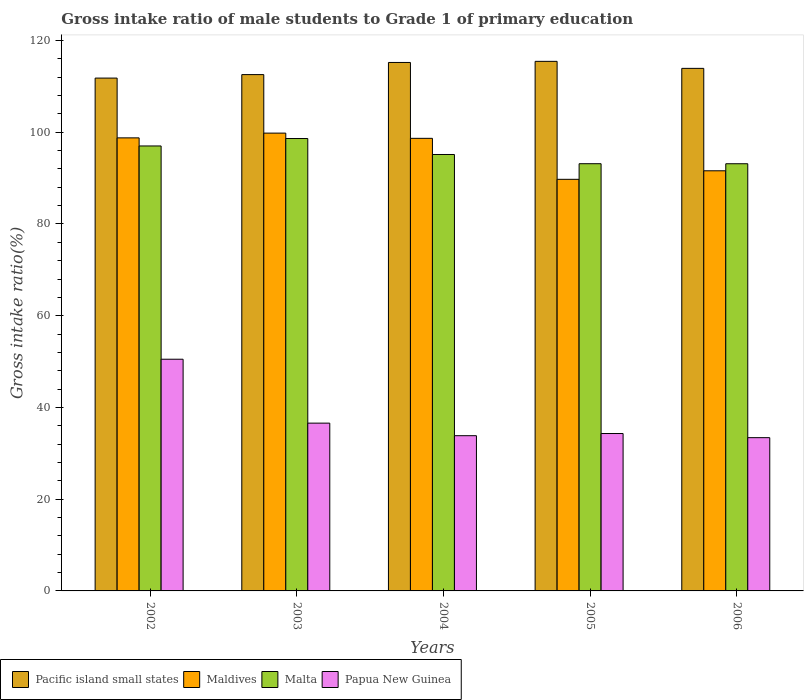How many different coloured bars are there?
Your response must be concise. 4. How many groups of bars are there?
Give a very brief answer. 5. How many bars are there on the 1st tick from the left?
Offer a very short reply. 4. How many bars are there on the 4th tick from the right?
Provide a succinct answer. 4. What is the gross intake ratio in Pacific island small states in 2004?
Your response must be concise. 115.21. Across all years, what is the maximum gross intake ratio in Maldives?
Keep it short and to the point. 99.81. Across all years, what is the minimum gross intake ratio in Pacific island small states?
Provide a short and direct response. 111.81. In which year was the gross intake ratio in Pacific island small states maximum?
Make the answer very short. 2005. What is the total gross intake ratio in Pacific island small states in the graph?
Provide a succinct answer. 568.95. What is the difference between the gross intake ratio in Malta in 2003 and that in 2005?
Offer a terse response. 5.49. What is the difference between the gross intake ratio in Maldives in 2005 and the gross intake ratio in Papua New Guinea in 2002?
Offer a very short reply. 39.22. What is the average gross intake ratio in Pacific island small states per year?
Your answer should be compact. 113.79. In the year 2004, what is the difference between the gross intake ratio in Maldives and gross intake ratio in Papua New Guinea?
Give a very brief answer. 64.83. In how many years, is the gross intake ratio in Malta greater than 32 %?
Your answer should be compact. 5. What is the ratio of the gross intake ratio in Maldives in 2003 to that in 2005?
Make the answer very short. 1.11. Is the gross intake ratio in Papua New Guinea in 2003 less than that in 2004?
Offer a terse response. No. Is the difference between the gross intake ratio in Maldives in 2002 and 2005 greater than the difference between the gross intake ratio in Papua New Guinea in 2002 and 2005?
Make the answer very short. No. What is the difference between the highest and the second highest gross intake ratio in Papua New Guinea?
Give a very brief answer. 13.93. What is the difference between the highest and the lowest gross intake ratio in Papua New Guinea?
Offer a terse response. 17.1. In how many years, is the gross intake ratio in Pacific island small states greater than the average gross intake ratio in Pacific island small states taken over all years?
Your response must be concise. 3. What does the 3rd bar from the left in 2003 represents?
Your answer should be very brief. Malta. What does the 3rd bar from the right in 2005 represents?
Ensure brevity in your answer.  Maldives. How many years are there in the graph?
Provide a short and direct response. 5. Are the values on the major ticks of Y-axis written in scientific E-notation?
Your response must be concise. No. How many legend labels are there?
Your response must be concise. 4. What is the title of the graph?
Make the answer very short. Gross intake ratio of male students to Grade 1 of primary education. What is the label or title of the Y-axis?
Offer a terse response. Gross intake ratio(%). What is the Gross intake ratio(%) of Pacific island small states in 2002?
Keep it short and to the point. 111.81. What is the Gross intake ratio(%) in Maldives in 2002?
Provide a succinct answer. 98.77. What is the Gross intake ratio(%) of Malta in 2002?
Keep it short and to the point. 97.01. What is the Gross intake ratio(%) in Papua New Guinea in 2002?
Make the answer very short. 50.51. What is the Gross intake ratio(%) in Pacific island small states in 2003?
Make the answer very short. 112.56. What is the Gross intake ratio(%) in Maldives in 2003?
Make the answer very short. 99.81. What is the Gross intake ratio(%) in Malta in 2003?
Give a very brief answer. 98.63. What is the Gross intake ratio(%) in Papua New Guinea in 2003?
Make the answer very short. 36.58. What is the Gross intake ratio(%) in Pacific island small states in 2004?
Offer a very short reply. 115.21. What is the Gross intake ratio(%) of Maldives in 2004?
Offer a very short reply. 98.67. What is the Gross intake ratio(%) in Malta in 2004?
Your answer should be compact. 95.15. What is the Gross intake ratio(%) in Papua New Guinea in 2004?
Give a very brief answer. 33.84. What is the Gross intake ratio(%) of Pacific island small states in 2005?
Keep it short and to the point. 115.45. What is the Gross intake ratio(%) in Maldives in 2005?
Your answer should be compact. 89.74. What is the Gross intake ratio(%) of Malta in 2005?
Give a very brief answer. 93.14. What is the Gross intake ratio(%) of Papua New Guinea in 2005?
Offer a terse response. 34.31. What is the Gross intake ratio(%) in Pacific island small states in 2006?
Make the answer very short. 113.92. What is the Gross intake ratio(%) in Maldives in 2006?
Make the answer very short. 91.59. What is the Gross intake ratio(%) in Malta in 2006?
Provide a succinct answer. 93.13. What is the Gross intake ratio(%) in Papua New Guinea in 2006?
Give a very brief answer. 33.41. Across all years, what is the maximum Gross intake ratio(%) in Pacific island small states?
Your answer should be very brief. 115.45. Across all years, what is the maximum Gross intake ratio(%) of Maldives?
Give a very brief answer. 99.81. Across all years, what is the maximum Gross intake ratio(%) of Malta?
Give a very brief answer. 98.63. Across all years, what is the maximum Gross intake ratio(%) of Papua New Guinea?
Keep it short and to the point. 50.51. Across all years, what is the minimum Gross intake ratio(%) in Pacific island small states?
Provide a short and direct response. 111.81. Across all years, what is the minimum Gross intake ratio(%) of Maldives?
Offer a very short reply. 89.74. Across all years, what is the minimum Gross intake ratio(%) of Malta?
Provide a short and direct response. 93.13. Across all years, what is the minimum Gross intake ratio(%) in Papua New Guinea?
Make the answer very short. 33.41. What is the total Gross intake ratio(%) in Pacific island small states in the graph?
Offer a terse response. 568.95. What is the total Gross intake ratio(%) in Maldives in the graph?
Give a very brief answer. 478.57. What is the total Gross intake ratio(%) in Malta in the graph?
Give a very brief answer. 477.05. What is the total Gross intake ratio(%) in Papua New Guinea in the graph?
Provide a succinct answer. 188.66. What is the difference between the Gross intake ratio(%) of Pacific island small states in 2002 and that in 2003?
Provide a short and direct response. -0.76. What is the difference between the Gross intake ratio(%) of Maldives in 2002 and that in 2003?
Your response must be concise. -1.03. What is the difference between the Gross intake ratio(%) in Malta in 2002 and that in 2003?
Keep it short and to the point. -1.62. What is the difference between the Gross intake ratio(%) in Papua New Guinea in 2002 and that in 2003?
Your answer should be compact. 13.93. What is the difference between the Gross intake ratio(%) in Pacific island small states in 2002 and that in 2004?
Keep it short and to the point. -3.4. What is the difference between the Gross intake ratio(%) in Maldives in 2002 and that in 2004?
Your response must be concise. 0.1. What is the difference between the Gross intake ratio(%) in Malta in 2002 and that in 2004?
Give a very brief answer. 1.86. What is the difference between the Gross intake ratio(%) of Papua New Guinea in 2002 and that in 2004?
Provide a succinct answer. 16.67. What is the difference between the Gross intake ratio(%) in Pacific island small states in 2002 and that in 2005?
Give a very brief answer. -3.65. What is the difference between the Gross intake ratio(%) in Maldives in 2002 and that in 2005?
Give a very brief answer. 9.04. What is the difference between the Gross intake ratio(%) in Malta in 2002 and that in 2005?
Your answer should be compact. 3.87. What is the difference between the Gross intake ratio(%) in Papua New Guinea in 2002 and that in 2005?
Your answer should be compact. 16.2. What is the difference between the Gross intake ratio(%) in Pacific island small states in 2002 and that in 2006?
Offer a very short reply. -2.12. What is the difference between the Gross intake ratio(%) in Maldives in 2002 and that in 2006?
Ensure brevity in your answer.  7.18. What is the difference between the Gross intake ratio(%) in Malta in 2002 and that in 2006?
Give a very brief answer. 3.88. What is the difference between the Gross intake ratio(%) in Papua New Guinea in 2002 and that in 2006?
Your answer should be compact. 17.1. What is the difference between the Gross intake ratio(%) of Pacific island small states in 2003 and that in 2004?
Offer a very short reply. -2.64. What is the difference between the Gross intake ratio(%) in Maldives in 2003 and that in 2004?
Keep it short and to the point. 1.14. What is the difference between the Gross intake ratio(%) in Malta in 2003 and that in 2004?
Your response must be concise. 3.48. What is the difference between the Gross intake ratio(%) of Papua New Guinea in 2003 and that in 2004?
Make the answer very short. 2.74. What is the difference between the Gross intake ratio(%) in Pacific island small states in 2003 and that in 2005?
Offer a terse response. -2.89. What is the difference between the Gross intake ratio(%) of Maldives in 2003 and that in 2005?
Keep it short and to the point. 10.07. What is the difference between the Gross intake ratio(%) of Malta in 2003 and that in 2005?
Offer a terse response. 5.49. What is the difference between the Gross intake ratio(%) in Papua New Guinea in 2003 and that in 2005?
Offer a very short reply. 2.27. What is the difference between the Gross intake ratio(%) of Pacific island small states in 2003 and that in 2006?
Give a very brief answer. -1.36. What is the difference between the Gross intake ratio(%) of Maldives in 2003 and that in 2006?
Give a very brief answer. 8.21. What is the difference between the Gross intake ratio(%) in Malta in 2003 and that in 2006?
Ensure brevity in your answer.  5.5. What is the difference between the Gross intake ratio(%) in Papua New Guinea in 2003 and that in 2006?
Make the answer very short. 3.17. What is the difference between the Gross intake ratio(%) in Pacific island small states in 2004 and that in 2005?
Offer a terse response. -0.24. What is the difference between the Gross intake ratio(%) in Maldives in 2004 and that in 2005?
Offer a terse response. 8.93. What is the difference between the Gross intake ratio(%) of Malta in 2004 and that in 2005?
Offer a terse response. 2.01. What is the difference between the Gross intake ratio(%) of Papua New Guinea in 2004 and that in 2005?
Your answer should be compact. -0.47. What is the difference between the Gross intake ratio(%) of Pacific island small states in 2004 and that in 2006?
Offer a very short reply. 1.29. What is the difference between the Gross intake ratio(%) of Maldives in 2004 and that in 2006?
Your answer should be compact. 7.07. What is the difference between the Gross intake ratio(%) in Malta in 2004 and that in 2006?
Your answer should be very brief. 2.02. What is the difference between the Gross intake ratio(%) of Papua New Guinea in 2004 and that in 2006?
Ensure brevity in your answer.  0.43. What is the difference between the Gross intake ratio(%) of Pacific island small states in 2005 and that in 2006?
Make the answer very short. 1.53. What is the difference between the Gross intake ratio(%) of Maldives in 2005 and that in 2006?
Your response must be concise. -1.86. What is the difference between the Gross intake ratio(%) of Malta in 2005 and that in 2006?
Keep it short and to the point. 0.01. What is the difference between the Gross intake ratio(%) in Papua New Guinea in 2005 and that in 2006?
Offer a terse response. 0.9. What is the difference between the Gross intake ratio(%) of Pacific island small states in 2002 and the Gross intake ratio(%) of Maldives in 2003?
Your response must be concise. 12. What is the difference between the Gross intake ratio(%) of Pacific island small states in 2002 and the Gross intake ratio(%) of Malta in 2003?
Your response must be concise. 13.18. What is the difference between the Gross intake ratio(%) of Pacific island small states in 2002 and the Gross intake ratio(%) of Papua New Guinea in 2003?
Offer a terse response. 75.22. What is the difference between the Gross intake ratio(%) of Maldives in 2002 and the Gross intake ratio(%) of Malta in 2003?
Provide a succinct answer. 0.14. What is the difference between the Gross intake ratio(%) of Maldives in 2002 and the Gross intake ratio(%) of Papua New Guinea in 2003?
Your answer should be very brief. 62.19. What is the difference between the Gross intake ratio(%) of Malta in 2002 and the Gross intake ratio(%) of Papua New Guinea in 2003?
Make the answer very short. 60.43. What is the difference between the Gross intake ratio(%) in Pacific island small states in 2002 and the Gross intake ratio(%) in Maldives in 2004?
Offer a very short reply. 13.14. What is the difference between the Gross intake ratio(%) of Pacific island small states in 2002 and the Gross intake ratio(%) of Malta in 2004?
Your answer should be compact. 16.66. What is the difference between the Gross intake ratio(%) in Pacific island small states in 2002 and the Gross intake ratio(%) in Papua New Guinea in 2004?
Offer a terse response. 77.97. What is the difference between the Gross intake ratio(%) in Maldives in 2002 and the Gross intake ratio(%) in Malta in 2004?
Your response must be concise. 3.63. What is the difference between the Gross intake ratio(%) in Maldives in 2002 and the Gross intake ratio(%) in Papua New Guinea in 2004?
Your answer should be compact. 64.93. What is the difference between the Gross intake ratio(%) of Malta in 2002 and the Gross intake ratio(%) of Papua New Guinea in 2004?
Ensure brevity in your answer.  63.17. What is the difference between the Gross intake ratio(%) in Pacific island small states in 2002 and the Gross intake ratio(%) in Maldives in 2005?
Ensure brevity in your answer.  22.07. What is the difference between the Gross intake ratio(%) in Pacific island small states in 2002 and the Gross intake ratio(%) in Malta in 2005?
Your answer should be very brief. 18.67. What is the difference between the Gross intake ratio(%) in Pacific island small states in 2002 and the Gross intake ratio(%) in Papua New Guinea in 2005?
Offer a very short reply. 77.49. What is the difference between the Gross intake ratio(%) in Maldives in 2002 and the Gross intake ratio(%) in Malta in 2005?
Ensure brevity in your answer.  5.63. What is the difference between the Gross intake ratio(%) in Maldives in 2002 and the Gross intake ratio(%) in Papua New Guinea in 2005?
Offer a terse response. 64.46. What is the difference between the Gross intake ratio(%) in Malta in 2002 and the Gross intake ratio(%) in Papua New Guinea in 2005?
Provide a succinct answer. 62.69. What is the difference between the Gross intake ratio(%) in Pacific island small states in 2002 and the Gross intake ratio(%) in Maldives in 2006?
Your answer should be very brief. 20.21. What is the difference between the Gross intake ratio(%) of Pacific island small states in 2002 and the Gross intake ratio(%) of Malta in 2006?
Your response must be concise. 18.68. What is the difference between the Gross intake ratio(%) of Pacific island small states in 2002 and the Gross intake ratio(%) of Papua New Guinea in 2006?
Offer a terse response. 78.39. What is the difference between the Gross intake ratio(%) in Maldives in 2002 and the Gross intake ratio(%) in Malta in 2006?
Your response must be concise. 5.64. What is the difference between the Gross intake ratio(%) of Maldives in 2002 and the Gross intake ratio(%) of Papua New Guinea in 2006?
Give a very brief answer. 65.36. What is the difference between the Gross intake ratio(%) in Malta in 2002 and the Gross intake ratio(%) in Papua New Guinea in 2006?
Give a very brief answer. 63.6. What is the difference between the Gross intake ratio(%) in Pacific island small states in 2003 and the Gross intake ratio(%) in Maldives in 2004?
Your response must be concise. 13.9. What is the difference between the Gross intake ratio(%) in Pacific island small states in 2003 and the Gross intake ratio(%) in Malta in 2004?
Keep it short and to the point. 17.42. What is the difference between the Gross intake ratio(%) of Pacific island small states in 2003 and the Gross intake ratio(%) of Papua New Guinea in 2004?
Your answer should be very brief. 78.72. What is the difference between the Gross intake ratio(%) in Maldives in 2003 and the Gross intake ratio(%) in Malta in 2004?
Give a very brief answer. 4.66. What is the difference between the Gross intake ratio(%) of Maldives in 2003 and the Gross intake ratio(%) of Papua New Guinea in 2004?
Provide a short and direct response. 65.97. What is the difference between the Gross intake ratio(%) in Malta in 2003 and the Gross intake ratio(%) in Papua New Guinea in 2004?
Your response must be concise. 64.79. What is the difference between the Gross intake ratio(%) of Pacific island small states in 2003 and the Gross intake ratio(%) of Maldives in 2005?
Provide a succinct answer. 22.83. What is the difference between the Gross intake ratio(%) in Pacific island small states in 2003 and the Gross intake ratio(%) in Malta in 2005?
Keep it short and to the point. 19.43. What is the difference between the Gross intake ratio(%) in Pacific island small states in 2003 and the Gross intake ratio(%) in Papua New Guinea in 2005?
Give a very brief answer. 78.25. What is the difference between the Gross intake ratio(%) in Maldives in 2003 and the Gross intake ratio(%) in Malta in 2005?
Ensure brevity in your answer.  6.67. What is the difference between the Gross intake ratio(%) of Maldives in 2003 and the Gross intake ratio(%) of Papua New Guinea in 2005?
Your answer should be compact. 65.49. What is the difference between the Gross intake ratio(%) in Malta in 2003 and the Gross intake ratio(%) in Papua New Guinea in 2005?
Provide a succinct answer. 64.31. What is the difference between the Gross intake ratio(%) in Pacific island small states in 2003 and the Gross intake ratio(%) in Maldives in 2006?
Provide a succinct answer. 20.97. What is the difference between the Gross intake ratio(%) in Pacific island small states in 2003 and the Gross intake ratio(%) in Malta in 2006?
Provide a short and direct response. 19.43. What is the difference between the Gross intake ratio(%) of Pacific island small states in 2003 and the Gross intake ratio(%) of Papua New Guinea in 2006?
Offer a very short reply. 79.15. What is the difference between the Gross intake ratio(%) in Maldives in 2003 and the Gross intake ratio(%) in Malta in 2006?
Your response must be concise. 6.67. What is the difference between the Gross intake ratio(%) of Maldives in 2003 and the Gross intake ratio(%) of Papua New Guinea in 2006?
Provide a succinct answer. 66.39. What is the difference between the Gross intake ratio(%) in Malta in 2003 and the Gross intake ratio(%) in Papua New Guinea in 2006?
Make the answer very short. 65.22. What is the difference between the Gross intake ratio(%) in Pacific island small states in 2004 and the Gross intake ratio(%) in Maldives in 2005?
Offer a terse response. 25.47. What is the difference between the Gross intake ratio(%) in Pacific island small states in 2004 and the Gross intake ratio(%) in Malta in 2005?
Your answer should be compact. 22.07. What is the difference between the Gross intake ratio(%) in Pacific island small states in 2004 and the Gross intake ratio(%) in Papua New Guinea in 2005?
Give a very brief answer. 80.89. What is the difference between the Gross intake ratio(%) of Maldives in 2004 and the Gross intake ratio(%) of Malta in 2005?
Your answer should be very brief. 5.53. What is the difference between the Gross intake ratio(%) in Maldives in 2004 and the Gross intake ratio(%) in Papua New Guinea in 2005?
Your answer should be compact. 64.35. What is the difference between the Gross intake ratio(%) of Malta in 2004 and the Gross intake ratio(%) of Papua New Guinea in 2005?
Make the answer very short. 60.83. What is the difference between the Gross intake ratio(%) of Pacific island small states in 2004 and the Gross intake ratio(%) of Maldives in 2006?
Offer a very short reply. 23.61. What is the difference between the Gross intake ratio(%) of Pacific island small states in 2004 and the Gross intake ratio(%) of Malta in 2006?
Offer a terse response. 22.08. What is the difference between the Gross intake ratio(%) in Pacific island small states in 2004 and the Gross intake ratio(%) in Papua New Guinea in 2006?
Provide a short and direct response. 81.8. What is the difference between the Gross intake ratio(%) of Maldives in 2004 and the Gross intake ratio(%) of Malta in 2006?
Ensure brevity in your answer.  5.54. What is the difference between the Gross intake ratio(%) in Maldives in 2004 and the Gross intake ratio(%) in Papua New Guinea in 2006?
Your answer should be compact. 65.26. What is the difference between the Gross intake ratio(%) in Malta in 2004 and the Gross intake ratio(%) in Papua New Guinea in 2006?
Your response must be concise. 61.73. What is the difference between the Gross intake ratio(%) in Pacific island small states in 2005 and the Gross intake ratio(%) in Maldives in 2006?
Ensure brevity in your answer.  23.86. What is the difference between the Gross intake ratio(%) of Pacific island small states in 2005 and the Gross intake ratio(%) of Malta in 2006?
Offer a terse response. 22.32. What is the difference between the Gross intake ratio(%) in Pacific island small states in 2005 and the Gross intake ratio(%) in Papua New Guinea in 2006?
Your answer should be very brief. 82.04. What is the difference between the Gross intake ratio(%) in Maldives in 2005 and the Gross intake ratio(%) in Malta in 2006?
Your answer should be compact. -3.4. What is the difference between the Gross intake ratio(%) in Maldives in 2005 and the Gross intake ratio(%) in Papua New Guinea in 2006?
Keep it short and to the point. 56.32. What is the difference between the Gross intake ratio(%) of Malta in 2005 and the Gross intake ratio(%) of Papua New Guinea in 2006?
Make the answer very short. 59.73. What is the average Gross intake ratio(%) in Pacific island small states per year?
Offer a terse response. 113.79. What is the average Gross intake ratio(%) in Maldives per year?
Keep it short and to the point. 95.71. What is the average Gross intake ratio(%) in Malta per year?
Your response must be concise. 95.41. What is the average Gross intake ratio(%) of Papua New Guinea per year?
Ensure brevity in your answer.  37.73. In the year 2002, what is the difference between the Gross intake ratio(%) in Pacific island small states and Gross intake ratio(%) in Maldives?
Provide a short and direct response. 13.03. In the year 2002, what is the difference between the Gross intake ratio(%) in Pacific island small states and Gross intake ratio(%) in Malta?
Offer a very short reply. 14.8. In the year 2002, what is the difference between the Gross intake ratio(%) in Pacific island small states and Gross intake ratio(%) in Papua New Guinea?
Provide a short and direct response. 61.29. In the year 2002, what is the difference between the Gross intake ratio(%) of Maldives and Gross intake ratio(%) of Malta?
Provide a short and direct response. 1.76. In the year 2002, what is the difference between the Gross intake ratio(%) of Maldives and Gross intake ratio(%) of Papua New Guinea?
Your answer should be compact. 48.26. In the year 2002, what is the difference between the Gross intake ratio(%) in Malta and Gross intake ratio(%) in Papua New Guinea?
Provide a succinct answer. 46.49. In the year 2003, what is the difference between the Gross intake ratio(%) of Pacific island small states and Gross intake ratio(%) of Maldives?
Your answer should be very brief. 12.76. In the year 2003, what is the difference between the Gross intake ratio(%) of Pacific island small states and Gross intake ratio(%) of Malta?
Keep it short and to the point. 13.94. In the year 2003, what is the difference between the Gross intake ratio(%) of Pacific island small states and Gross intake ratio(%) of Papua New Guinea?
Your answer should be very brief. 75.98. In the year 2003, what is the difference between the Gross intake ratio(%) in Maldives and Gross intake ratio(%) in Malta?
Make the answer very short. 1.18. In the year 2003, what is the difference between the Gross intake ratio(%) in Maldives and Gross intake ratio(%) in Papua New Guinea?
Give a very brief answer. 63.23. In the year 2003, what is the difference between the Gross intake ratio(%) in Malta and Gross intake ratio(%) in Papua New Guinea?
Your answer should be compact. 62.05. In the year 2004, what is the difference between the Gross intake ratio(%) of Pacific island small states and Gross intake ratio(%) of Maldives?
Ensure brevity in your answer.  16.54. In the year 2004, what is the difference between the Gross intake ratio(%) in Pacific island small states and Gross intake ratio(%) in Malta?
Give a very brief answer. 20.06. In the year 2004, what is the difference between the Gross intake ratio(%) of Pacific island small states and Gross intake ratio(%) of Papua New Guinea?
Provide a succinct answer. 81.37. In the year 2004, what is the difference between the Gross intake ratio(%) of Maldives and Gross intake ratio(%) of Malta?
Your response must be concise. 3.52. In the year 2004, what is the difference between the Gross intake ratio(%) of Maldives and Gross intake ratio(%) of Papua New Guinea?
Keep it short and to the point. 64.83. In the year 2004, what is the difference between the Gross intake ratio(%) in Malta and Gross intake ratio(%) in Papua New Guinea?
Make the answer very short. 61.31. In the year 2005, what is the difference between the Gross intake ratio(%) in Pacific island small states and Gross intake ratio(%) in Maldives?
Provide a succinct answer. 25.72. In the year 2005, what is the difference between the Gross intake ratio(%) of Pacific island small states and Gross intake ratio(%) of Malta?
Your answer should be compact. 22.31. In the year 2005, what is the difference between the Gross intake ratio(%) of Pacific island small states and Gross intake ratio(%) of Papua New Guinea?
Your response must be concise. 81.14. In the year 2005, what is the difference between the Gross intake ratio(%) of Maldives and Gross intake ratio(%) of Malta?
Make the answer very short. -3.4. In the year 2005, what is the difference between the Gross intake ratio(%) of Maldives and Gross intake ratio(%) of Papua New Guinea?
Offer a terse response. 55.42. In the year 2005, what is the difference between the Gross intake ratio(%) of Malta and Gross intake ratio(%) of Papua New Guinea?
Offer a very short reply. 58.82. In the year 2006, what is the difference between the Gross intake ratio(%) of Pacific island small states and Gross intake ratio(%) of Maldives?
Offer a very short reply. 22.33. In the year 2006, what is the difference between the Gross intake ratio(%) of Pacific island small states and Gross intake ratio(%) of Malta?
Keep it short and to the point. 20.79. In the year 2006, what is the difference between the Gross intake ratio(%) of Pacific island small states and Gross intake ratio(%) of Papua New Guinea?
Offer a very short reply. 80.51. In the year 2006, what is the difference between the Gross intake ratio(%) in Maldives and Gross intake ratio(%) in Malta?
Keep it short and to the point. -1.54. In the year 2006, what is the difference between the Gross intake ratio(%) of Maldives and Gross intake ratio(%) of Papua New Guinea?
Your response must be concise. 58.18. In the year 2006, what is the difference between the Gross intake ratio(%) in Malta and Gross intake ratio(%) in Papua New Guinea?
Ensure brevity in your answer.  59.72. What is the ratio of the Gross intake ratio(%) of Malta in 2002 to that in 2003?
Provide a succinct answer. 0.98. What is the ratio of the Gross intake ratio(%) of Papua New Guinea in 2002 to that in 2003?
Offer a very short reply. 1.38. What is the ratio of the Gross intake ratio(%) in Pacific island small states in 2002 to that in 2004?
Your answer should be compact. 0.97. What is the ratio of the Gross intake ratio(%) in Malta in 2002 to that in 2004?
Provide a short and direct response. 1.02. What is the ratio of the Gross intake ratio(%) of Papua New Guinea in 2002 to that in 2004?
Offer a very short reply. 1.49. What is the ratio of the Gross intake ratio(%) of Pacific island small states in 2002 to that in 2005?
Offer a very short reply. 0.97. What is the ratio of the Gross intake ratio(%) in Maldives in 2002 to that in 2005?
Offer a very short reply. 1.1. What is the ratio of the Gross intake ratio(%) of Malta in 2002 to that in 2005?
Your answer should be very brief. 1.04. What is the ratio of the Gross intake ratio(%) of Papua New Guinea in 2002 to that in 2005?
Your answer should be compact. 1.47. What is the ratio of the Gross intake ratio(%) of Pacific island small states in 2002 to that in 2006?
Offer a terse response. 0.98. What is the ratio of the Gross intake ratio(%) of Maldives in 2002 to that in 2006?
Provide a short and direct response. 1.08. What is the ratio of the Gross intake ratio(%) in Malta in 2002 to that in 2006?
Give a very brief answer. 1.04. What is the ratio of the Gross intake ratio(%) of Papua New Guinea in 2002 to that in 2006?
Offer a terse response. 1.51. What is the ratio of the Gross intake ratio(%) of Pacific island small states in 2003 to that in 2004?
Ensure brevity in your answer.  0.98. What is the ratio of the Gross intake ratio(%) of Maldives in 2003 to that in 2004?
Your answer should be compact. 1.01. What is the ratio of the Gross intake ratio(%) of Malta in 2003 to that in 2004?
Give a very brief answer. 1.04. What is the ratio of the Gross intake ratio(%) of Papua New Guinea in 2003 to that in 2004?
Make the answer very short. 1.08. What is the ratio of the Gross intake ratio(%) in Maldives in 2003 to that in 2005?
Keep it short and to the point. 1.11. What is the ratio of the Gross intake ratio(%) in Malta in 2003 to that in 2005?
Your answer should be very brief. 1.06. What is the ratio of the Gross intake ratio(%) in Papua New Guinea in 2003 to that in 2005?
Your answer should be very brief. 1.07. What is the ratio of the Gross intake ratio(%) in Pacific island small states in 2003 to that in 2006?
Ensure brevity in your answer.  0.99. What is the ratio of the Gross intake ratio(%) of Maldives in 2003 to that in 2006?
Offer a very short reply. 1.09. What is the ratio of the Gross intake ratio(%) of Malta in 2003 to that in 2006?
Provide a short and direct response. 1.06. What is the ratio of the Gross intake ratio(%) of Papua New Guinea in 2003 to that in 2006?
Make the answer very short. 1.09. What is the ratio of the Gross intake ratio(%) in Maldives in 2004 to that in 2005?
Ensure brevity in your answer.  1.1. What is the ratio of the Gross intake ratio(%) of Malta in 2004 to that in 2005?
Your response must be concise. 1.02. What is the ratio of the Gross intake ratio(%) in Papua New Guinea in 2004 to that in 2005?
Your response must be concise. 0.99. What is the ratio of the Gross intake ratio(%) in Pacific island small states in 2004 to that in 2006?
Your answer should be very brief. 1.01. What is the ratio of the Gross intake ratio(%) in Maldives in 2004 to that in 2006?
Ensure brevity in your answer.  1.08. What is the ratio of the Gross intake ratio(%) in Malta in 2004 to that in 2006?
Offer a very short reply. 1.02. What is the ratio of the Gross intake ratio(%) in Papua New Guinea in 2004 to that in 2006?
Offer a terse response. 1.01. What is the ratio of the Gross intake ratio(%) of Pacific island small states in 2005 to that in 2006?
Make the answer very short. 1.01. What is the ratio of the Gross intake ratio(%) in Maldives in 2005 to that in 2006?
Your response must be concise. 0.98. What is the difference between the highest and the second highest Gross intake ratio(%) of Pacific island small states?
Your response must be concise. 0.24. What is the difference between the highest and the second highest Gross intake ratio(%) in Maldives?
Your answer should be compact. 1.03. What is the difference between the highest and the second highest Gross intake ratio(%) of Malta?
Make the answer very short. 1.62. What is the difference between the highest and the second highest Gross intake ratio(%) in Papua New Guinea?
Your answer should be compact. 13.93. What is the difference between the highest and the lowest Gross intake ratio(%) of Pacific island small states?
Provide a succinct answer. 3.65. What is the difference between the highest and the lowest Gross intake ratio(%) of Maldives?
Give a very brief answer. 10.07. What is the difference between the highest and the lowest Gross intake ratio(%) of Malta?
Your response must be concise. 5.5. What is the difference between the highest and the lowest Gross intake ratio(%) of Papua New Guinea?
Your answer should be very brief. 17.1. 